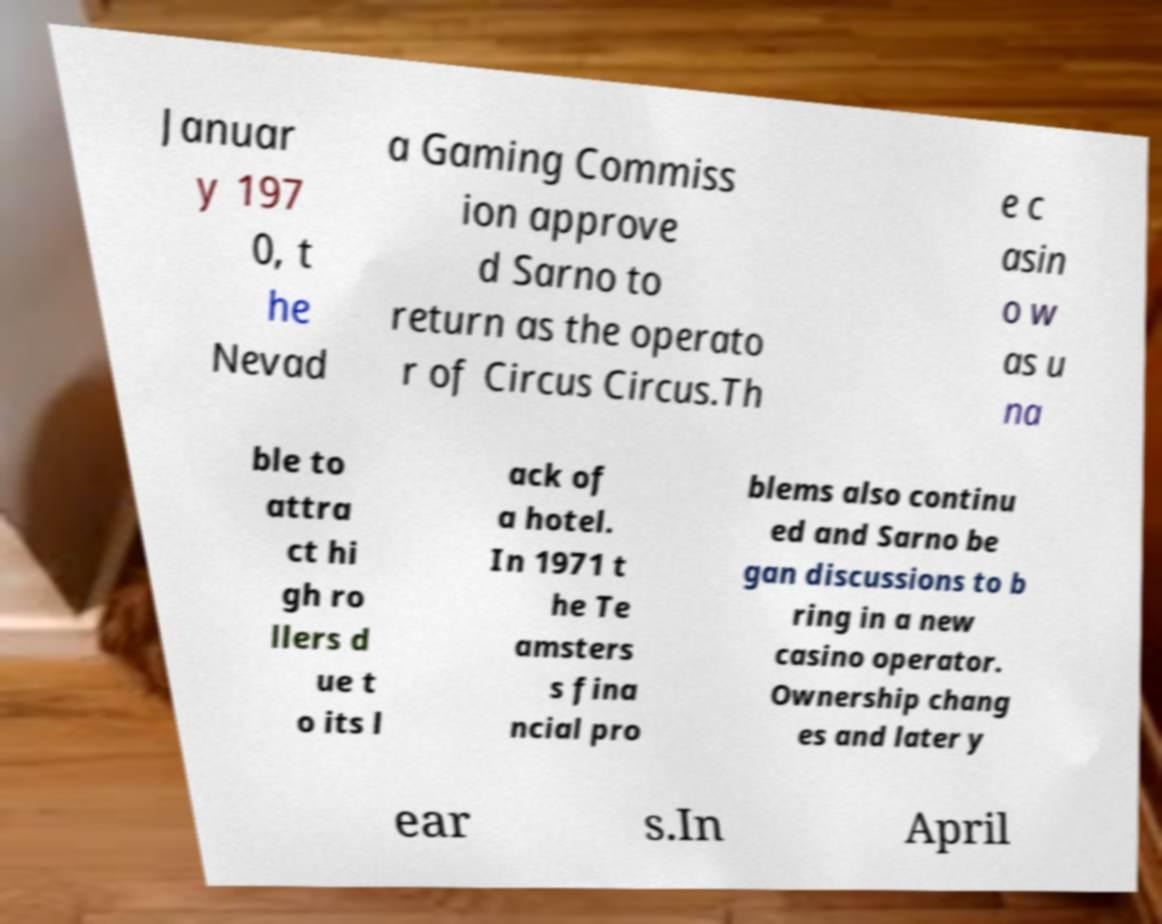I need the written content from this picture converted into text. Can you do that? Januar y 197 0, t he Nevad a Gaming Commiss ion approve d Sarno to return as the operato r of Circus Circus.Th e c asin o w as u na ble to attra ct hi gh ro llers d ue t o its l ack of a hotel. In 1971 t he Te amsters s fina ncial pro blems also continu ed and Sarno be gan discussions to b ring in a new casino operator. Ownership chang es and later y ear s.In April 